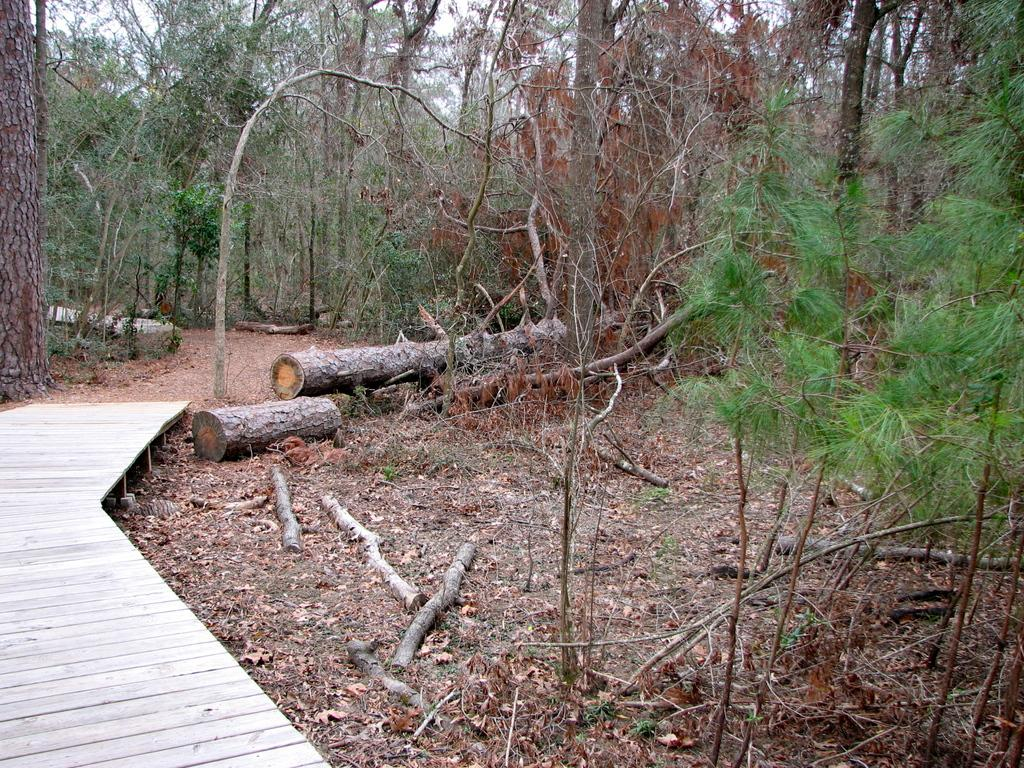What type of natural environment is depicted in the image? The image contains a view of the forest. What can be seen at the forefront of the image? There are wooden trunks in the front of the image. Can you describe any structures present in the image? There is a small wooden bridge on the left side of the image. What is the taste of the mother's railway in the image? There is no mother or railway present in the image, so it is not possible to determine the taste. 